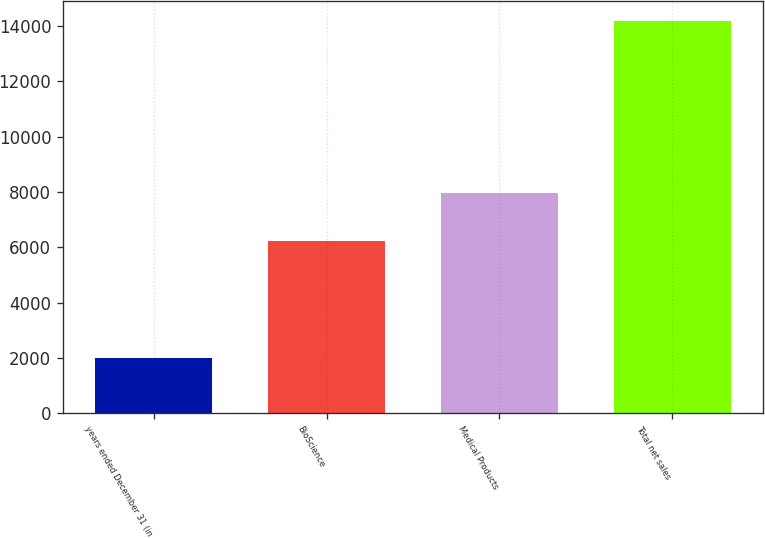Convert chart. <chart><loc_0><loc_0><loc_500><loc_500><bar_chart><fcel>years ended December 31 (in<fcel>BioScience<fcel>Medical Products<fcel>Total net sales<nl><fcel>2012<fcel>6237<fcel>7953<fcel>14190<nl></chart> 